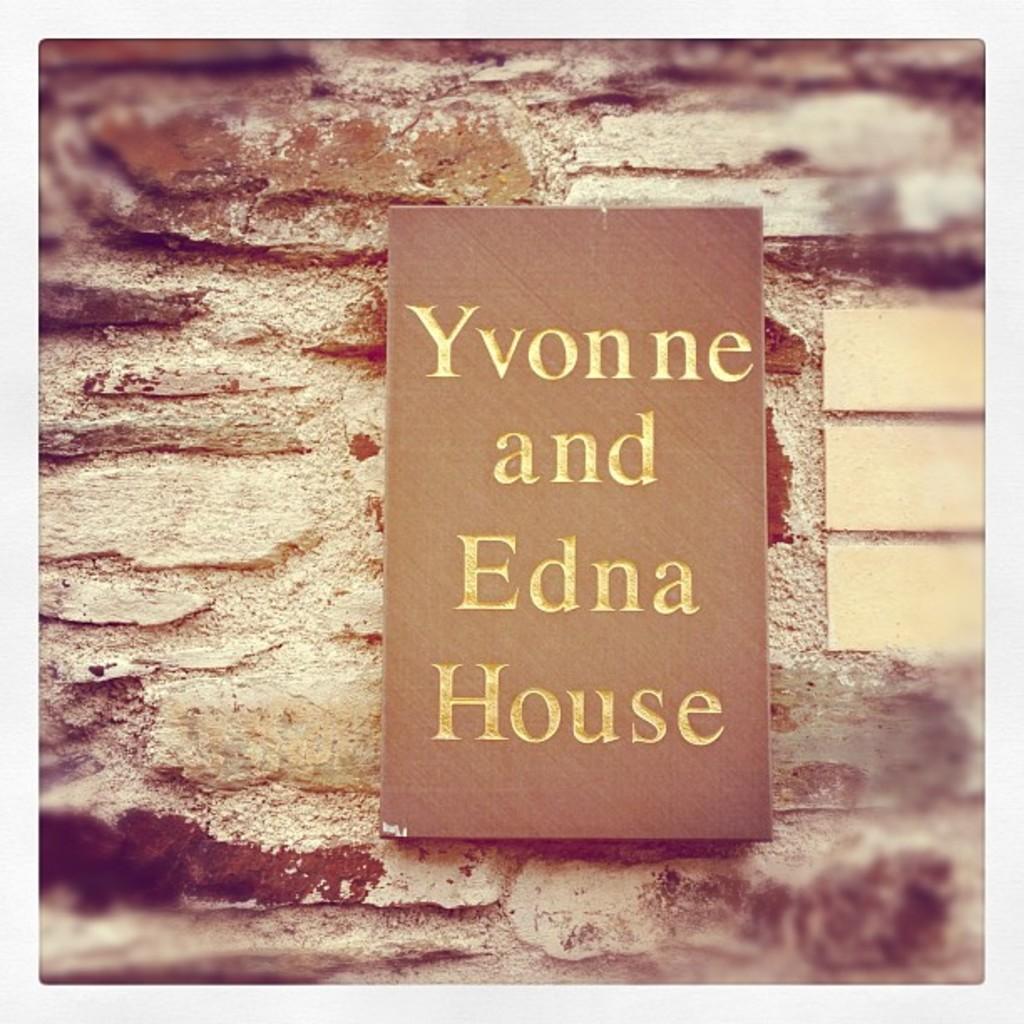Whose house is it?
Ensure brevity in your answer.  Yvonne and edna. How many people own the house?
Make the answer very short. 2. 